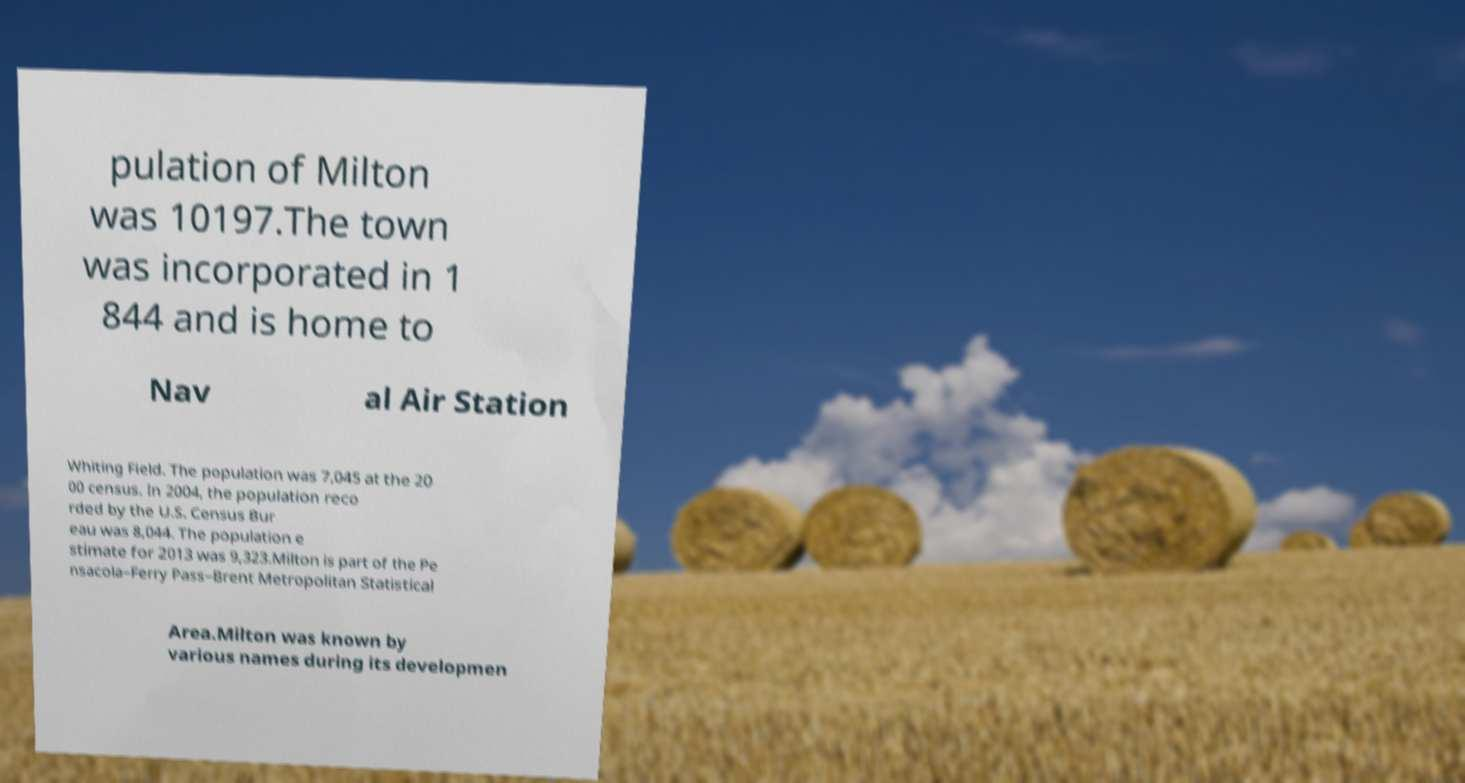Could you assist in decoding the text presented in this image and type it out clearly? pulation of Milton was 10197.The town was incorporated in 1 844 and is home to Nav al Air Station Whiting Field. The population was 7,045 at the 20 00 census. In 2004, the population reco rded by the U.S. Census Bur eau was 8,044. The population e stimate for 2013 was 9,323.Milton is part of the Pe nsacola–Ferry Pass–Brent Metropolitan Statistical Area.Milton was known by various names during its developmen 